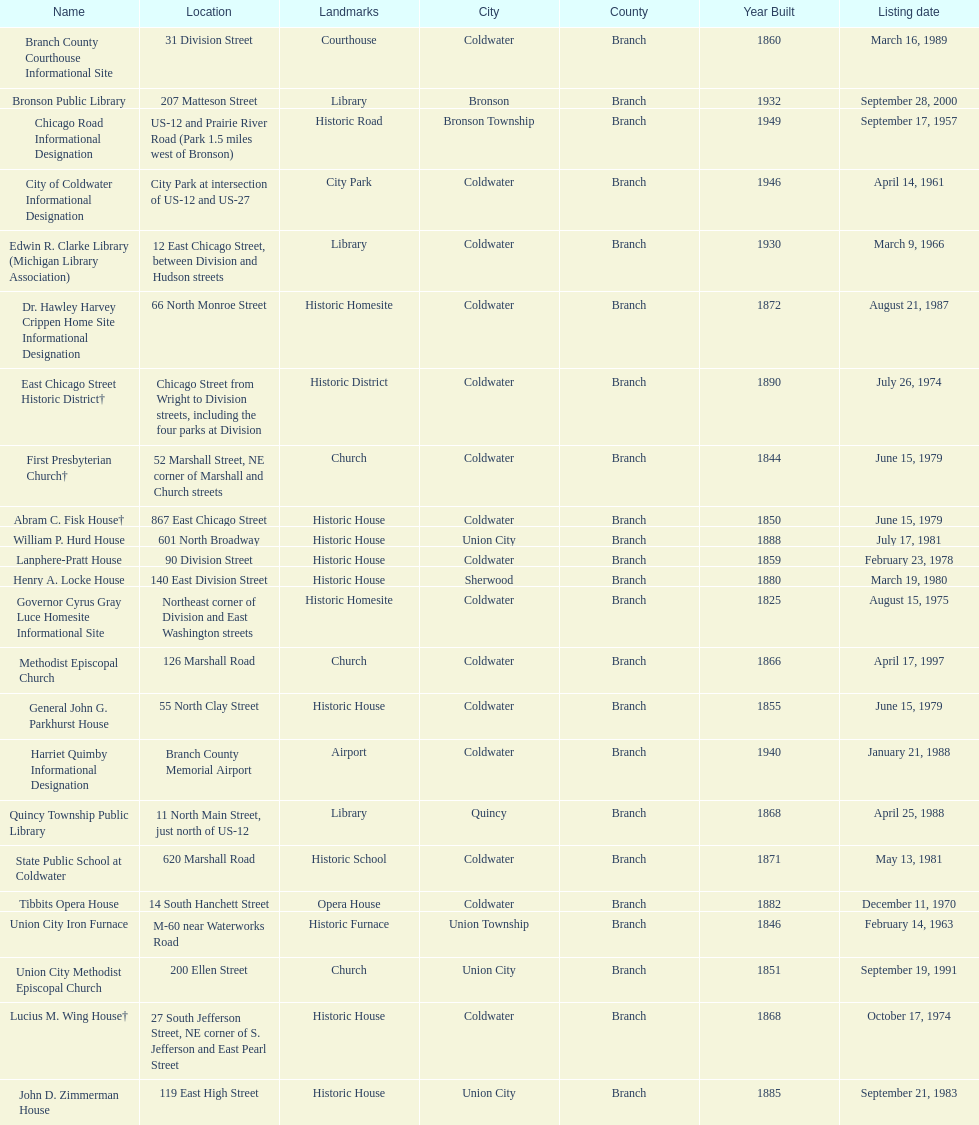Parse the table in full. {'header': ['Name', 'Location', 'Landmarks', 'City', 'County', 'Year Built', 'Listing date'], 'rows': [['Branch County Courthouse Informational Site', '31 Division Street', 'Courthouse', 'Coldwater', 'Branch', '1860', 'March 16, 1989'], ['Bronson Public Library', '207 Matteson Street', 'Library', 'Bronson', 'Branch', '1932', 'September 28, 2000'], ['Chicago Road Informational Designation', 'US-12 and Prairie River Road (Park 1.5 miles west of Bronson)', 'Historic Road', 'Bronson Township', 'Branch', '1949', 'September 17, 1957'], ['City of Coldwater Informational Designation', 'City Park at intersection of US-12 and US-27', 'City Park', 'Coldwater', 'Branch', '1946', 'April 14, 1961'], ['Edwin R. Clarke Library (Michigan Library Association)', '12 East Chicago Street, between Division and Hudson streets', 'Library', 'Coldwater', 'Branch', '1930', 'March 9, 1966'], ['Dr. Hawley Harvey Crippen Home Site Informational Designation', '66 North Monroe Street', 'Historic Homesite', 'Coldwater', 'Branch', '1872', 'August 21, 1987'], ['East Chicago Street Historic District†', 'Chicago Street from Wright to Division streets, including the four parks at Division', 'Historic District', 'Coldwater', 'Branch', '1890', 'July 26, 1974'], ['First Presbyterian Church†', '52 Marshall Street, NE corner of Marshall and Church streets', 'Church', 'Coldwater', 'Branch', '1844', 'June 15, 1979'], ['Abram C. Fisk House†', '867 East Chicago Street', 'Historic House', 'Coldwater', 'Branch', '1850', 'June 15, 1979'], ['William P. Hurd House', '601 North Broadway', 'Historic House', 'Union City', 'Branch', '1888', 'July 17, 1981'], ['Lanphere-Pratt House', '90 Division Street', 'Historic House', 'Coldwater', 'Branch', '1859', 'February 23, 1978'], ['Henry A. Locke House', '140 East Division Street', 'Historic House', 'Sherwood', 'Branch', '1880', 'March 19, 1980'], ['Governor Cyrus Gray Luce Homesite Informational Site', 'Northeast corner of Division and East Washington streets', 'Historic Homesite', 'Coldwater', 'Branch', '1825', 'August 15, 1975'], ['Methodist Episcopal Church', '126 Marshall Road', 'Church', 'Coldwater', 'Branch', '1866', 'April 17, 1997'], ['General John G. Parkhurst House', '55 North Clay Street', 'Historic House', 'Coldwater', 'Branch', '1855', 'June 15, 1979'], ['Harriet Quimby Informational Designation', 'Branch County Memorial Airport', 'Airport', 'Coldwater', 'Branch', '1940', 'January 21, 1988'], ['Quincy Township Public Library', '11 North Main Street, just north of US-12', 'Library', 'Quincy', 'Branch', '1868', 'April 25, 1988'], ['State Public School at Coldwater', '620 Marshall Road', 'Historic School', 'Coldwater', 'Branch', '1871', 'May 13, 1981'], ['Tibbits Opera House', '14 South Hanchett Street', 'Opera House', 'Coldwater', 'Branch', '1882', 'December 11, 1970'], ['Union City Iron Furnace', 'M-60 near Waterworks Road', 'Historic Furnace', 'Union Township', 'Branch', '1846', 'February 14, 1963'], ['Union City Methodist Episcopal Church', '200 Ellen Street', 'Church', 'Union City', 'Branch', '1851', 'September 19, 1991'], ['Lucius M. Wing House†', '27 South Jefferson Street, NE corner of S. Jefferson and East Pearl Street', 'Historic House', 'Coldwater', 'Branch', '1868', 'October 17, 1974'], ['John D. Zimmerman House', '119 East High Street', 'Historic House', 'Union City', 'Branch', '1885', 'September 21, 1983']]} How many historic sites were listed before 1965? 3. 